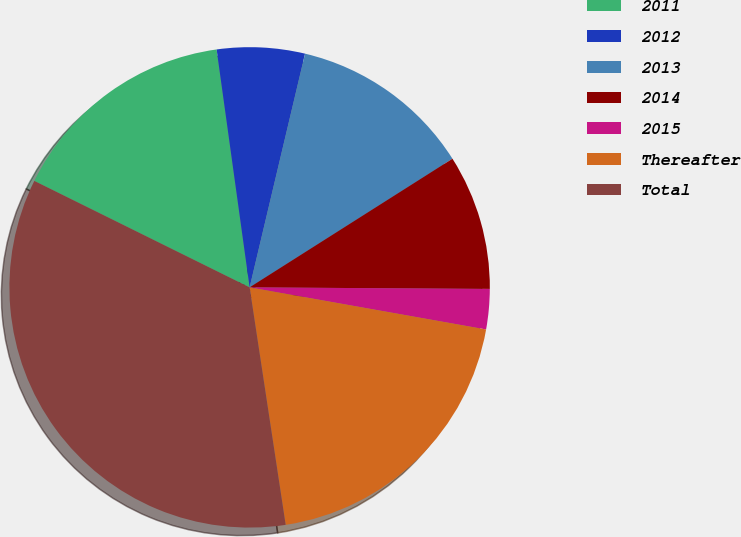Convert chart to OTSL. <chart><loc_0><loc_0><loc_500><loc_500><pie_chart><fcel>2011<fcel>2012<fcel>2013<fcel>2014<fcel>2015<fcel>Thereafter<fcel>Total<nl><fcel>15.5%<fcel>5.9%<fcel>12.3%<fcel>9.1%<fcel>2.7%<fcel>19.8%<fcel>34.71%<nl></chart> 